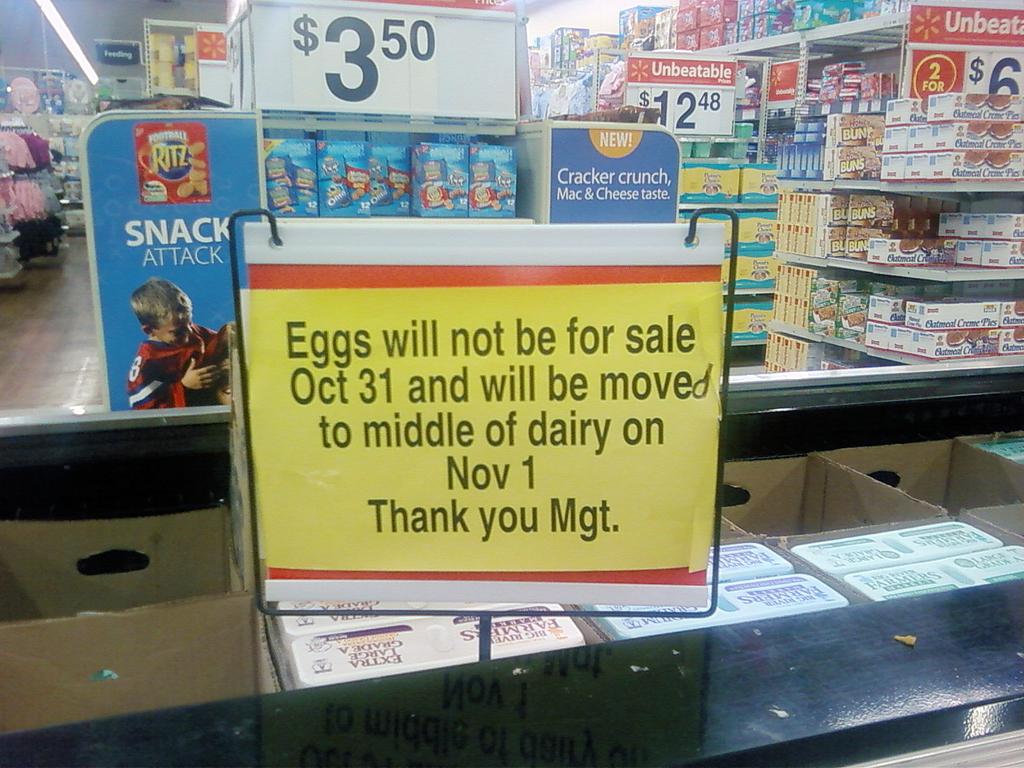Will eggs be more convenient to access once moved?
Provide a succinct answer. Unanswerable. Price on the top?
Provide a short and direct response. 3.50. 